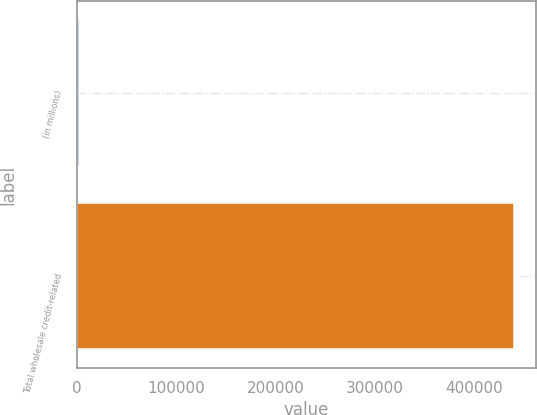<chart> <loc_0><loc_0><loc_500><loc_500><bar_chart><fcel>(in millions)<fcel>Total wholesale credit-related<nl><fcel>2008<fcel>440811<nl></chart> 